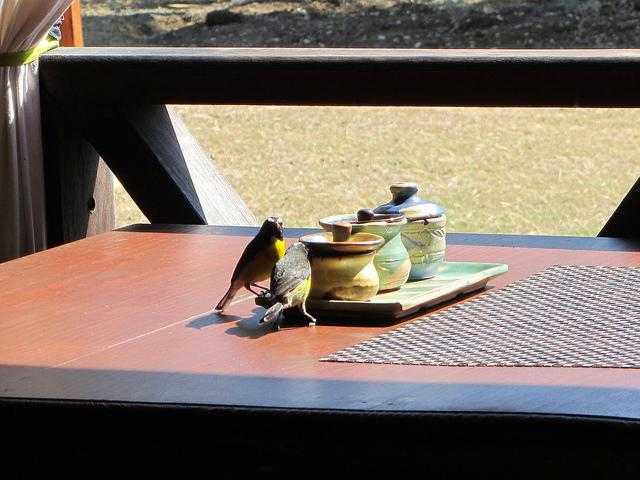Where is this table located at? Please explain your reasoning. patio. Looks like it's on an outdoor porch. 